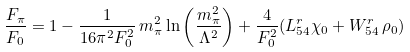Convert formula to latex. <formula><loc_0><loc_0><loc_500><loc_500>\frac { F _ { \pi } } { F _ { 0 } } = 1 - \frac { 1 } { 1 6 \pi ^ { 2 } F _ { 0 } ^ { 2 } } \, m _ { \pi } ^ { 2 } \ln \left ( \frac { m _ { \pi } ^ { 2 } } { \Lambda ^ { 2 } } \right ) + \frac { 4 } { F _ { 0 } ^ { 2 } } ( L ^ { r } _ { 5 4 } \chi _ { 0 } + W ^ { r } _ { 5 4 } \, \rho _ { 0 } )</formula> 